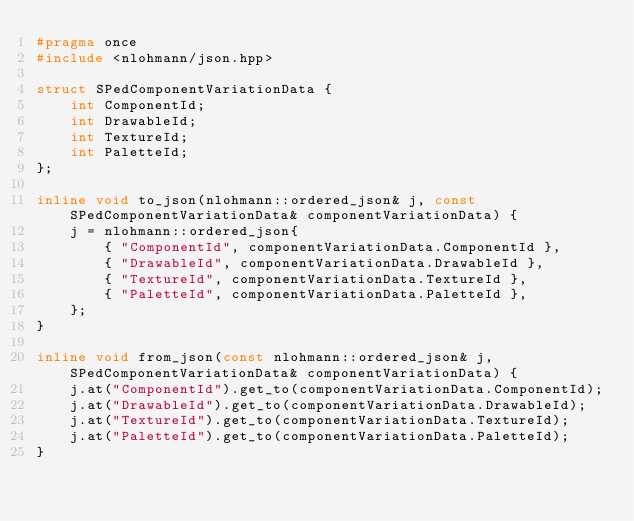<code> <loc_0><loc_0><loc_500><loc_500><_C++_>#pragma once
#include <nlohmann/json.hpp>

struct SPedComponentVariationData {
    int ComponentId;
    int DrawableId;
    int TextureId;
    int PaletteId;
};

inline void to_json(nlohmann::ordered_json& j, const SPedComponentVariationData& componentVariationData) {
    j = nlohmann::ordered_json{
        { "ComponentId", componentVariationData.ComponentId },
        { "DrawableId", componentVariationData.DrawableId },
        { "TextureId", componentVariationData.TextureId },
        { "PaletteId", componentVariationData.PaletteId },
    };
}

inline void from_json(const nlohmann::ordered_json& j, SPedComponentVariationData& componentVariationData) {
    j.at("ComponentId").get_to(componentVariationData.ComponentId);
    j.at("DrawableId").get_to(componentVariationData.DrawableId);
    j.at("TextureId").get_to(componentVariationData.TextureId);
    j.at("PaletteId").get_to(componentVariationData.PaletteId);
}
</code> 